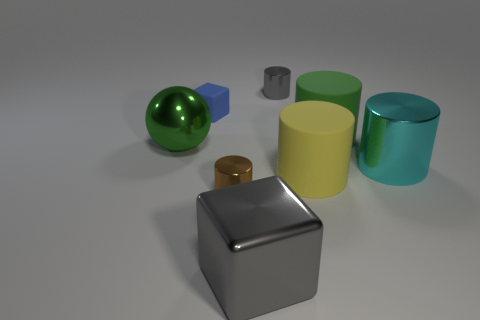Subtract all gray cylinders. How many cylinders are left? 4 Add 2 big green metallic cylinders. How many objects exist? 10 Subtract all blue cubes. How many cubes are left? 1 Subtract all tiny gray metal things. Subtract all cyan cylinders. How many objects are left? 6 Add 7 large shiny spheres. How many large shiny spheres are left? 8 Add 4 big yellow metal cylinders. How many big yellow metal cylinders exist? 4 Subtract 0 cyan cubes. How many objects are left? 8 Subtract all spheres. How many objects are left? 7 Subtract all cyan cubes. Subtract all red balls. How many cubes are left? 2 